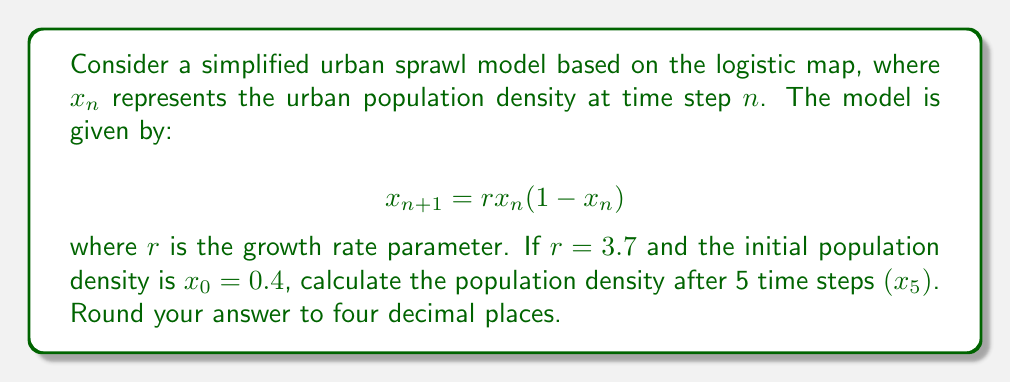Show me your answer to this math problem. To solve this problem, we need to iterate the logistic map equation for 5 time steps:

1) First, let's define our parameters:
   $r = 3.7$
   $x_0 = 0.4$

2) Now, we'll calculate each step:

   For $n = 0$:
   $x_1 = r * x_0 * (1 - x_0)$
   $x_1 = 3.7 * 0.4 * (1 - 0.4) = 3.7 * 0.4 * 0.6 = 0.888$

   For $n = 1$:
   $x_2 = r * x_1 * (1 - x_1)$
   $x_2 = 3.7 * 0.888 * (1 - 0.888) = 3.7 * 0.888 * 0.112 = 0.3682$

   For $n = 2$:
   $x_3 = r * x_2 * (1 - x_2)$
   $x_3 = 3.7 * 0.3682 * (1 - 0.3682) = 3.7 * 0.3682 * 0.6318 = 0.8615$

   For $n = 3$:
   $x_4 = r * x_3 * (1 - x_3)$
   $x_4 = 3.7 * 0.8615 * (1 - 0.8615) = 3.7 * 0.8615 * 0.1385 = 0.4411$

   For $n = 4$:
   $x_5 = r * x_4 * (1 - x_4)$
   $x_5 = 3.7 * 0.4411 * (1 - 0.4411) = 3.7 * 0.4411 * 0.5589 = 0.9124$

3) Rounding to four decimal places:
   $x_5 ≈ 0.9124$

This result shows how the population density fluctuates over time, demonstrating the chaotic behavior of urban sprawl in this simplified model.
Answer: 0.9124 